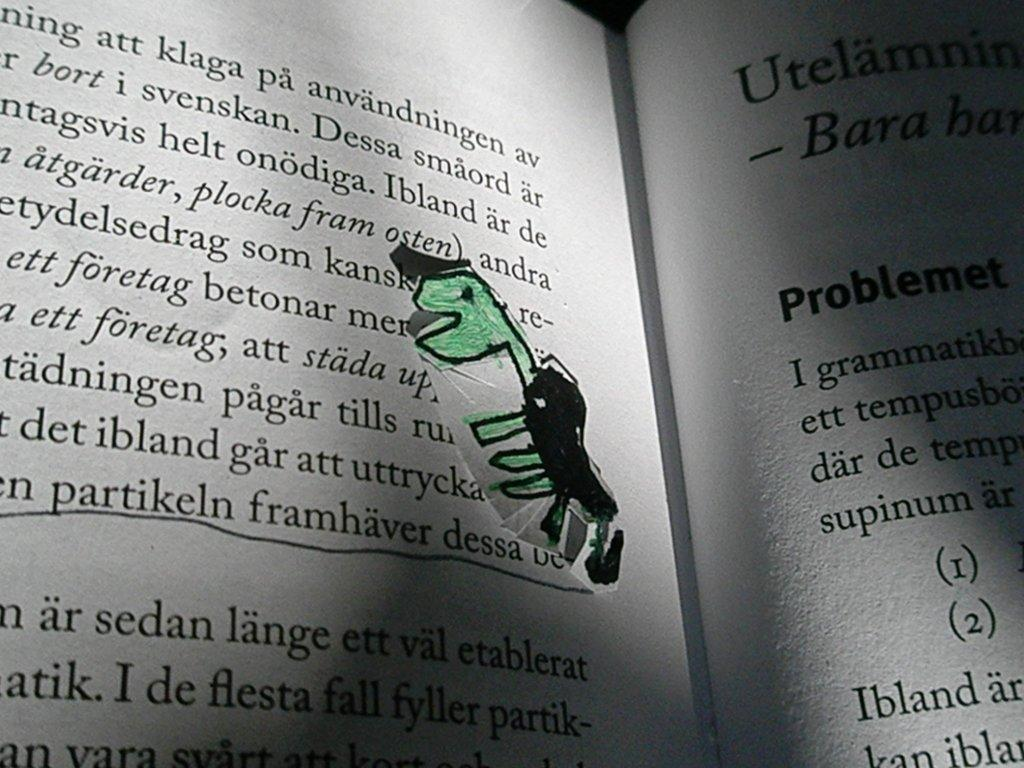<image>
Provide a brief description of the given image. The right page of an open book starts out with the partial word Utelamnin. 